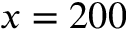Convert formula to latex. <formula><loc_0><loc_0><loc_500><loc_500>x = 2 0 0</formula> 